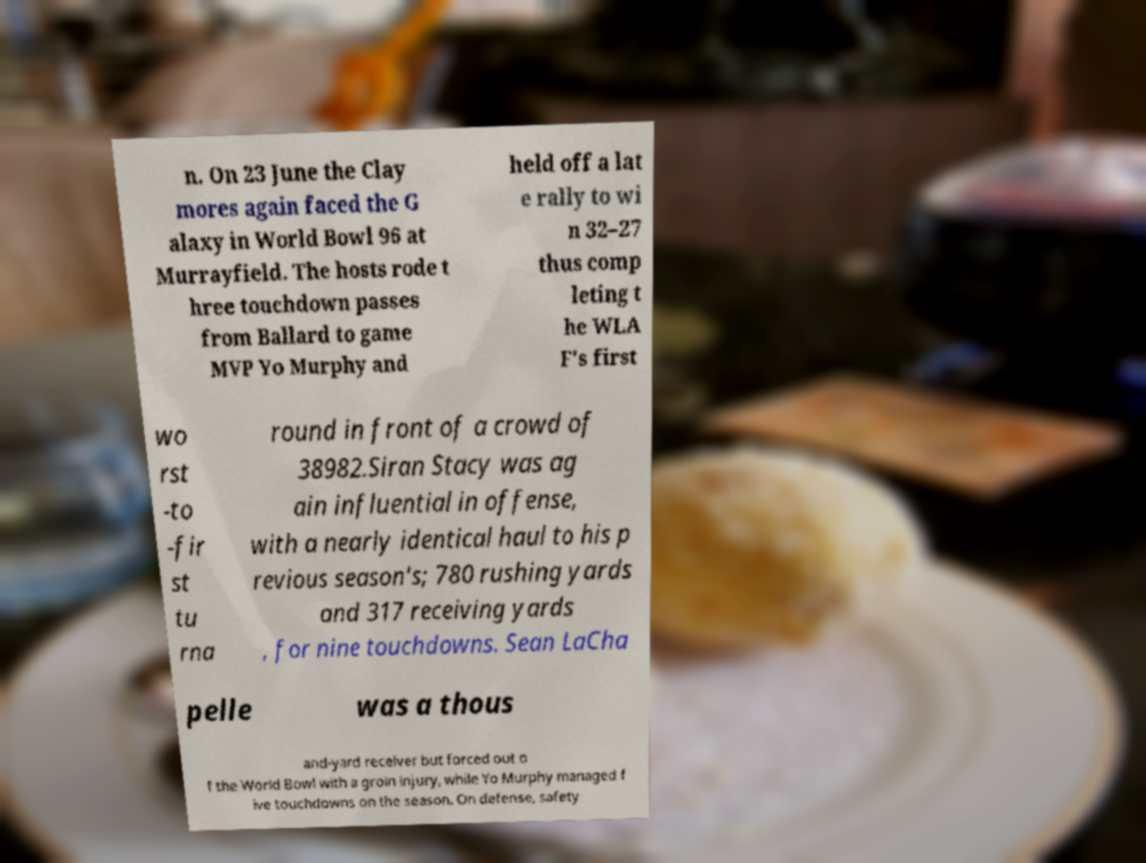Can you read and provide the text displayed in the image?This photo seems to have some interesting text. Can you extract and type it out for me? n. On 23 June the Clay mores again faced the G alaxy in World Bowl 96 at Murrayfield. The hosts rode t hree touchdown passes from Ballard to game MVP Yo Murphy and held off a lat e rally to wi n 32–27 thus comp leting t he WLA F's first wo rst -to -fir st tu rna round in front of a crowd of 38982.Siran Stacy was ag ain influential in offense, with a nearly identical haul to his p revious season's; 780 rushing yards and 317 receiving yards , for nine touchdowns. Sean LaCha pelle was a thous and-yard receiver but forced out o f the World Bowl with a groin injury, while Yo Murphy managed f ive touchdowns on the season. On defense, safety 